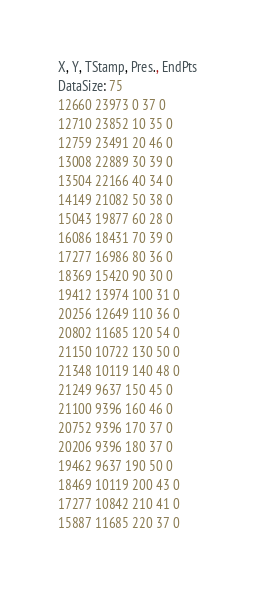<code> <loc_0><loc_0><loc_500><loc_500><_SML_>X, Y, TStamp, Pres., EndPts
DataSize: 75
12660 23973 0 37 0
12710 23852 10 35 0
12759 23491 20 46 0
13008 22889 30 39 0
13504 22166 40 34 0
14149 21082 50 38 0
15043 19877 60 28 0
16086 18431 70 39 0
17277 16986 80 36 0
18369 15420 90 30 0
19412 13974 100 31 0
20256 12649 110 36 0
20802 11685 120 54 0
21150 10722 130 50 0
21348 10119 140 48 0
21249 9637 150 45 0
21100 9396 160 46 0
20752 9396 170 37 0
20206 9396 180 37 0
19462 9637 190 50 0
18469 10119 200 43 0
17277 10842 210 41 0
15887 11685 220 37 0</code> 